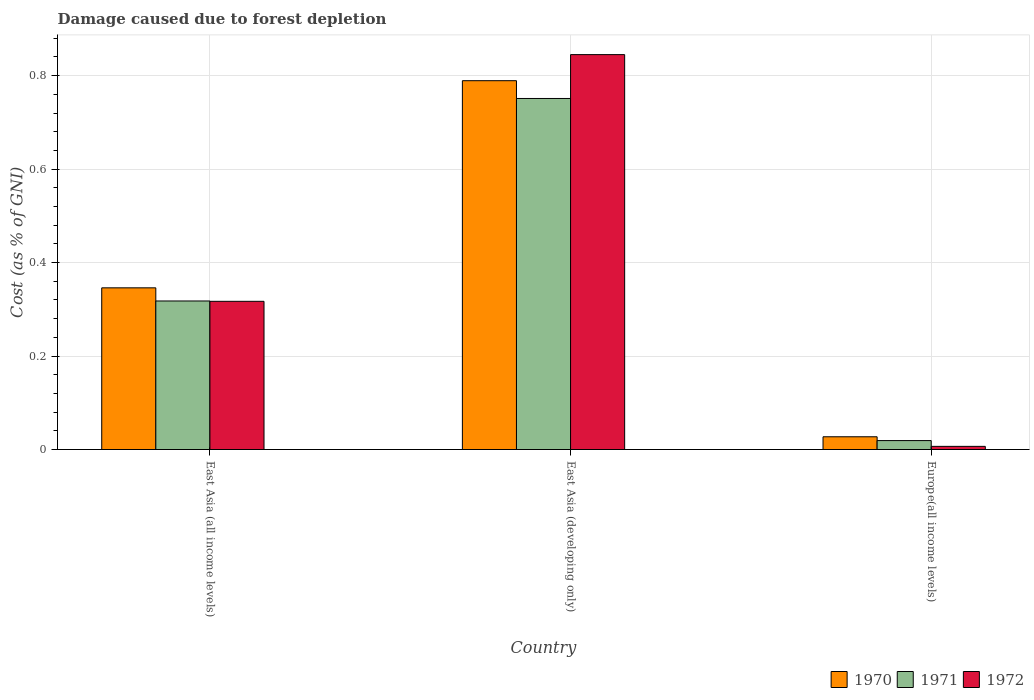How many groups of bars are there?
Make the answer very short. 3. Are the number of bars per tick equal to the number of legend labels?
Make the answer very short. Yes. Are the number of bars on each tick of the X-axis equal?
Offer a very short reply. Yes. How many bars are there on the 3rd tick from the left?
Provide a short and direct response. 3. How many bars are there on the 1st tick from the right?
Your answer should be compact. 3. What is the label of the 3rd group of bars from the left?
Your answer should be compact. Europe(all income levels). What is the cost of damage caused due to forest depletion in 1970 in East Asia (all income levels)?
Offer a terse response. 0.35. Across all countries, what is the maximum cost of damage caused due to forest depletion in 1970?
Your answer should be very brief. 0.79. Across all countries, what is the minimum cost of damage caused due to forest depletion in 1971?
Your answer should be compact. 0.02. In which country was the cost of damage caused due to forest depletion in 1971 maximum?
Provide a short and direct response. East Asia (developing only). In which country was the cost of damage caused due to forest depletion in 1971 minimum?
Make the answer very short. Europe(all income levels). What is the total cost of damage caused due to forest depletion in 1972 in the graph?
Provide a succinct answer. 1.17. What is the difference between the cost of damage caused due to forest depletion in 1972 in East Asia (all income levels) and that in East Asia (developing only)?
Provide a succinct answer. -0.53. What is the difference between the cost of damage caused due to forest depletion in 1970 in East Asia (all income levels) and the cost of damage caused due to forest depletion in 1972 in Europe(all income levels)?
Provide a succinct answer. 0.34. What is the average cost of damage caused due to forest depletion in 1971 per country?
Your answer should be compact. 0.36. What is the difference between the cost of damage caused due to forest depletion of/in 1971 and cost of damage caused due to forest depletion of/in 1972 in East Asia (developing only)?
Your response must be concise. -0.09. In how many countries, is the cost of damage caused due to forest depletion in 1972 greater than 0.24000000000000002 %?
Offer a terse response. 2. What is the ratio of the cost of damage caused due to forest depletion in 1970 in East Asia (developing only) to that in Europe(all income levels)?
Offer a very short reply. 28.94. Is the cost of damage caused due to forest depletion in 1972 in East Asia (all income levels) less than that in East Asia (developing only)?
Provide a short and direct response. Yes. Is the difference between the cost of damage caused due to forest depletion in 1971 in East Asia (all income levels) and Europe(all income levels) greater than the difference between the cost of damage caused due to forest depletion in 1972 in East Asia (all income levels) and Europe(all income levels)?
Keep it short and to the point. No. What is the difference between the highest and the second highest cost of damage caused due to forest depletion in 1970?
Your answer should be compact. 0.76. What is the difference between the highest and the lowest cost of damage caused due to forest depletion in 1972?
Your response must be concise. 0.84. What does the 2nd bar from the right in Europe(all income levels) represents?
Keep it short and to the point. 1971. Is it the case that in every country, the sum of the cost of damage caused due to forest depletion in 1972 and cost of damage caused due to forest depletion in 1970 is greater than the cost of damage caused due to forest depletion in 1971?
Make the answer very short. Yes. Are all the bars in the graph horizontal?
Give a very brief answer. No. How many countries are there in the graph?
Your answer should be compact. 3. Where does the legend appear in the graph?
Make the answer very short. Bottom right. How many legend labels are there?
Your answer should be compact. 3. What is the title of the graph?
Provide a short and direct response. Damage caused due to forest depletion. What is the label or title of the X-axis?
Give a very brief answer. Country. What is the label or title of the Y-axis?
Keep it short and to the point. Cost (as % of GNI). What is the Cost (as % of GNI) in 1970 in East Asia (all income levels)?
Your answer should be very brief. 0.35. What is the Cost (as % of GNI) of 1971 in East Asia (all income levels)?
Ensure brevity in your answer.  0.32. What is the Cost (as % of GNI) in 1972 in East Asia (all income levels)?
Offer a terse response. 0.32. What is the Cost (as % of GNI) of 1970 in East Asia (developing only)?
Your answer should be compact. 0.79. What is the Cost (as % of GNI) in 1971 in East Asia (developing only)?
Provide a short and direct response. 0.75. What is the Cost (as % of GNI) of 1972 in East Asia (developing only)?
Your answer should be compact. 0.84. What is the Cost (as % of GNI) of 1970 in Europe(all income levels)?
Give a very brief answer. 0.03. What is the Cost (as % of GNI) in 1971 in Europe(all income levels)?
Your answer should be compact. 0.02. What is the Cost (as % of GNI) of 1972 in Europe(all income levels)?
Offer a terse response. 0.01. Across all countries, what is the maximum Cost (as % of GNI) of 1970?
Make the answer very short. 0.79. Across all countries, what is the maximum Cost (as % of GNI) in 1971?
Ensure brevity in your answer.  0.75. Across all countries, what is the maximum Cost (as % of GNI) of 1972?
Provide a short and direct response. 0.84. Across all countries, what is the minimum Cost (as % of GNI) of 1970?
Provide a short and direct response. 0.03. Across all countries, what is the minimum Cost (as % of GNI) in 1971?
Ensure brevity in your answer.  0.02. Across all countries, what is the minimum Cost (as % of GNI) of 1972?
Your response must be concise. 0.01. What is the total Cost (as % of GNI) of 1970 in the graph?
Offer a very short reply. 1.16. What is the total Cost (as % of GNI) of 1971 in the graph?
Offer a very short reply. 1.09. What is the total Cost (as % of GNI) in 1972 in the graph?
Make the answer very short. 1.17. What is the difference between the Cost (as % of GNI) in 1970 in East Asia (all income levels) and that in East Asia (developing only)?
Provide a succinct answer. -0.44. What is the difference between the Cost (as % of GNI) in 1971 in East Asia (all income levels) and that in East Asia (developing only)?
Give a very brief answer. -0.43. What is the difference between the Cost (as % of GNI) in 1972 in East Asia (all income levels) and that in East Asia (developing only)?
Provide a short and direct response. -0.53. What is the difference between the Cost (as % of GNI) of 1970 in East Asia (all income levels) and that in Europe(all income levels)?
Your answer should be very brief. 0.32. What is the difference between the Cost (as % of GNI) in 1971 in East Asia (all income levels) and that in Europe(all income levels)?
Provide a succinct answer. 0.3. What is the difference between the Cost (as % of GNI) of 1972 in East Asia (all income levels) and that in Europe(all income levels)?
Keep it short and to the point. 0.31. What is the difference between the Cost (as % of GNI) in 1970 in East Asia (developing only) and that in Europe(all income levels)?
Provide a succinct answer. 0.76. What is the difference between the Cost (as % of GNI) in 1971 in East Asia (developing only) and that in Europe(all income levels)?
Your answer should be compact. 0.73. What is the difference between the Cost (as % of GNI) of 1972 in East Asia (developing only) and that in Europe(all income levels)?
Your answer should be very brief. 0.84. What is the difference between the Cost (as % of GNI) in 1970 in East Asia (all income levels) and the Cost (as % of GNI) in 1971 in East Asia (developing only)?
Your answer should be very brief. -0.41. What is the difference between the Cost (as % of GNI) in 1970 in East Asia (all income levels) and the Cost (as % of GNI) in 1972 in East Asia (developing only)?
Keep it short and to the point. -0.5. What is the difference between the Cost (as % of GNI) of 1971 in East Asia (all income levels) and the Cost (as % of GNI) of 1972 in East Asia (developing only)?
Your answer should be compact. -0.53. What is the difference between the Cost (as % of GNI) of 1970 in East Asia (all income levels) and the Cost (as % of GNI) of 1971 in Europe(all income levels)?
Make the answer very short. 0.33. What is the difference between the Cost (as % of GNI) in 1970 in East Asia (all income levels) and the Cost (as % of GNI) in 1972 in Europe(all income levels)?
Give a very brief answer. 0.34. What is the difference between the Cost (as % of GNI) of 1971 in East Asia (all income levels) and the Cost (as % of GNI) of 1972 in Europe(all income levels)?
Ensure brevity in your answer.  0.31. What is the difference between the Cost (as % of GNI) in 1970 in East Asia (developing only) and the Cost (as % of GNI) in 1971 in Europe(all income levels)?
Ensure brevity in your answer.  0.77. What is the difference between the Cost (as % of GNI) of 1970 in East Asia (developing only) and the Cost (as % of GNI) of 1972 in Europe(all income levels)?
Your answer should be very brief. 0.78. What is the difference between the Cost (as % of GNI) in 1971 in East Asia (developing only) and the Cost (as % of GNI) in 1972 in Europe(all income levels)?
Give a very brief answer. 0.74. What is the average Cost (as % of GNI) in 1970 per country?
Give a very brief answer. 0.39. What is the average Cost (as % of GNI) in 1971 per country?
Provide a short and direct response. 0.36. What is the average Cost (as % of GNI) of 1972 per country?
Offer a very short reply. 0.39. What is the difference between the Cost (as % of GNI) in 1970 and Cost (as % of GNI) in 1971 in East Asia (all income levels)?
Provide a short and direct response. 0.03. What is the difference between the Cost (as % of GNI) in 1970 and Cost (as % of GNI) in 1972 in East Asia (all income levels)?
Give a very brief answer. 0.03. What is the difference between the Cost (as % of GNI) in 1971 and Cost (as % of GNI) in 1972 in East Asia (all income levels)?
Ensure brevity in your answer.  0. What is the difference between the Cost (as % of GNI) of 1970 and Cost (as % of GNI) of 1971 in East Asia (developing only)?
Offer a very short reply. 0.04. What is the difference between the Cost (as % of GNI) of 1970 and Cost (as % of GNI) of 1972 in East Asia (developing only)?
Make the answer very short. -0.06. What is the difference between the Cost (as % of GNI) of 1971 and Cost (as % of GNI) of 1972 in East Asia (developing only)?
Ensure brevity in your answer.  -0.09. What is the difference between the Cost (as % of GNI) in 1970 and Cost (as % of GNI) in 1971 in Europe(all income levels)?
Provide a short and direct response. 0.01. What is the difference between the Cost (as % of GNI) in 1970 and Cost (as % of GNI) in 1972 in Europe(all income levels)?
Your answer should be compact. 0.02. What is the difference between the Cost (as % of GNI) of 1971 and Cost (as % of GNI) of 1972 in Europe(all income levels)?
Provide a short and direct response. 0.01. What is the ratio of the Cost (as % of GNI) in 1970 in East Asia (all income levels) to that in East Asia (developing only)?
Your answer should be compact. 0.44. What is the ratio of the Cost (as % of GNI) in 1971 in East Asia (all income levels) to that in East Asia (developing only)?
Ensure brevity in your answer.  0.42. What is the ratio of the Cost (as % of GNI) in 1972 in East Asia (all income levels) to that in East Asia (developing only)?
Your answer should be compact. 0.38. What is the ratio of the Cost (as % of GNI) in 1970 in East Asia (all income levels) to that in Europe(all income levels)?
Offer a very short reply. 12.69. What is the ratio of the Cost (as % of GNI) of 1971 in East Asia (all income levels) to that in Europe(all income levels)?
Provide a succinct answer. 16.64. What is the ratio of the Cost (as % of GNI) of 1972 in East Asia (all income levels) to that in Europe(all income levels)?
Make the answer very short. 47.11. What is the ratio of the Cost (as % of GNI) in 1970 in East Asia (developing only) to that in Europe(all income levels)?
Your response must be concise. 28.94. What is the ratio of the Cost (as % of GNI) in 1971 in East Asia (developing only) to that in Europe(all income levels)?
Your response must be concise. 39.33. What is the ratio of the Cost (as % of GNI) in 1972 in East Asia (developing only) to that in Europe(all income levels)?
Your answer should be compact. 125.54. What is the difference between the highest and the second highest Cost (as % of GNI) of 1970?
Provide a succinct answer. 0.44. What is the difference between the highest and the second highest Cost (as % of GNI) in 1971?
Provide a succinct answer. 0.43. What is the difference between the highest and the second highest Cost (as % of GNI) of 1972?
Your answer should be very brief. 0.53. What is the difference between the highest and the lowest Cost (as % of GNI) of 1970?
Give a very brief answer. 0.76. What is the difference between the highest and the lowest Cost (as % of GNI) of 1971?
Make the answer very short. 0.73. What is the difference between the highest and the lowest Cost (as % of GNI) in 1972?
Offer a very short reply. 0.84. 